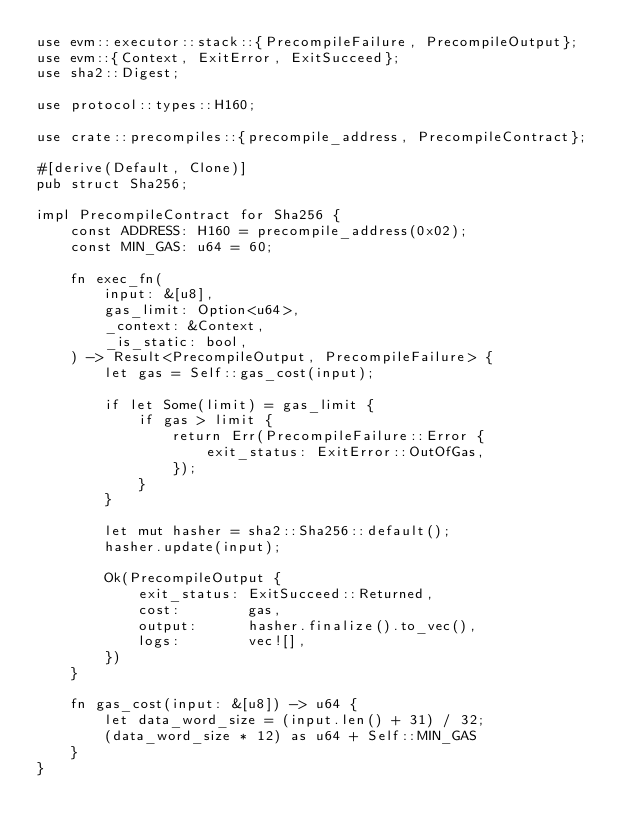Convert code to text. <code><loc_0><loc_0><loc_500><loc_500><_Rust_>use evm::executor::stack::{PrecompileFailure, PrecompileOutput};
use evm::{Context, ExitError, ExitSucceed};
use sha2::Digest;

use protocol::types::H160;

use crate::precompiles::{precompile_address, PrecompileContract};

#[derive(Default, Clone)]
pub struct Sha256;

impl PrecompileContract for Sha256 {
    const ADDRESS: H160 = precompile_address(0x02);
    const MIN_GAS: u64 = 60;

    fn exec_fn(
        input: &[u8],
        gas_limit: Option<u64>,
        _context: &Context,
        _is_static: bool,
    ) -> Result<PrecompileOutput, PrecompileFailure> {
        let gas = Self::gas_cost(input);

        if let Some(limit) = gas_limit {
            if gas > limit {
                return Err(PrecompileFailure::Error {
                    exit_status: ExitError::OutOfGas,
                });
            }
        }

        let mut hasher = sha2::Sha256::default();
        hasher.update(input);

        Ok(PrecompileOutput {
            exit_status: ExitSucceed::Returned,
            cost:        gas,
            output:      hasher.finalize().to_vec(),
            logs:        vec![],
        })
    }

    fn gas_cost(input: &[u8]) -> u64 {
        let data_word_size = (input.len() + 31) / 32;
        (data_word_size * 12) as u64 + Self::MIN_GAS
    }
}
</code> 